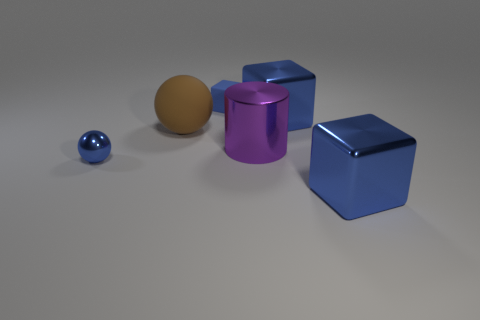What shape is the small thing that is the same color as the small matte cube?
Provide a succinct answer. Sphere. Is there anything else that is the same color as the tiny matte thing?
Offer a very short reply. Yes. Is the large cylinder made of the same material as the small thing right of the big brown ball?
Give a very brief answer. No. Is the color of the small cube the same as the tiny metal thing?
Your answer should be very brief. Yes. How many metallic balls are the same color as the tiny matte cube?
Make the answer very short. 1. There is a shiny block behind the large cylinder; does it have the same color as the small rubber cube?
Your answer should be compact. Yes. There is a matte cube that is the same color as the metallic sphere; what is its size?
Your answer should be very brief. Small. What is the size of the object that is on the right side of the purple thing and behind the brown matte sphere?
Ensure brevity in your answer.  Large. What material is the cube left of the big blue thing that is behind the large blue object that is in front of the shiny cylinder?
Provide a short and direct response. Rubber. What material is the tiny cube that is the same color as the shiny ball?
Your response must be concise. Rubber. 